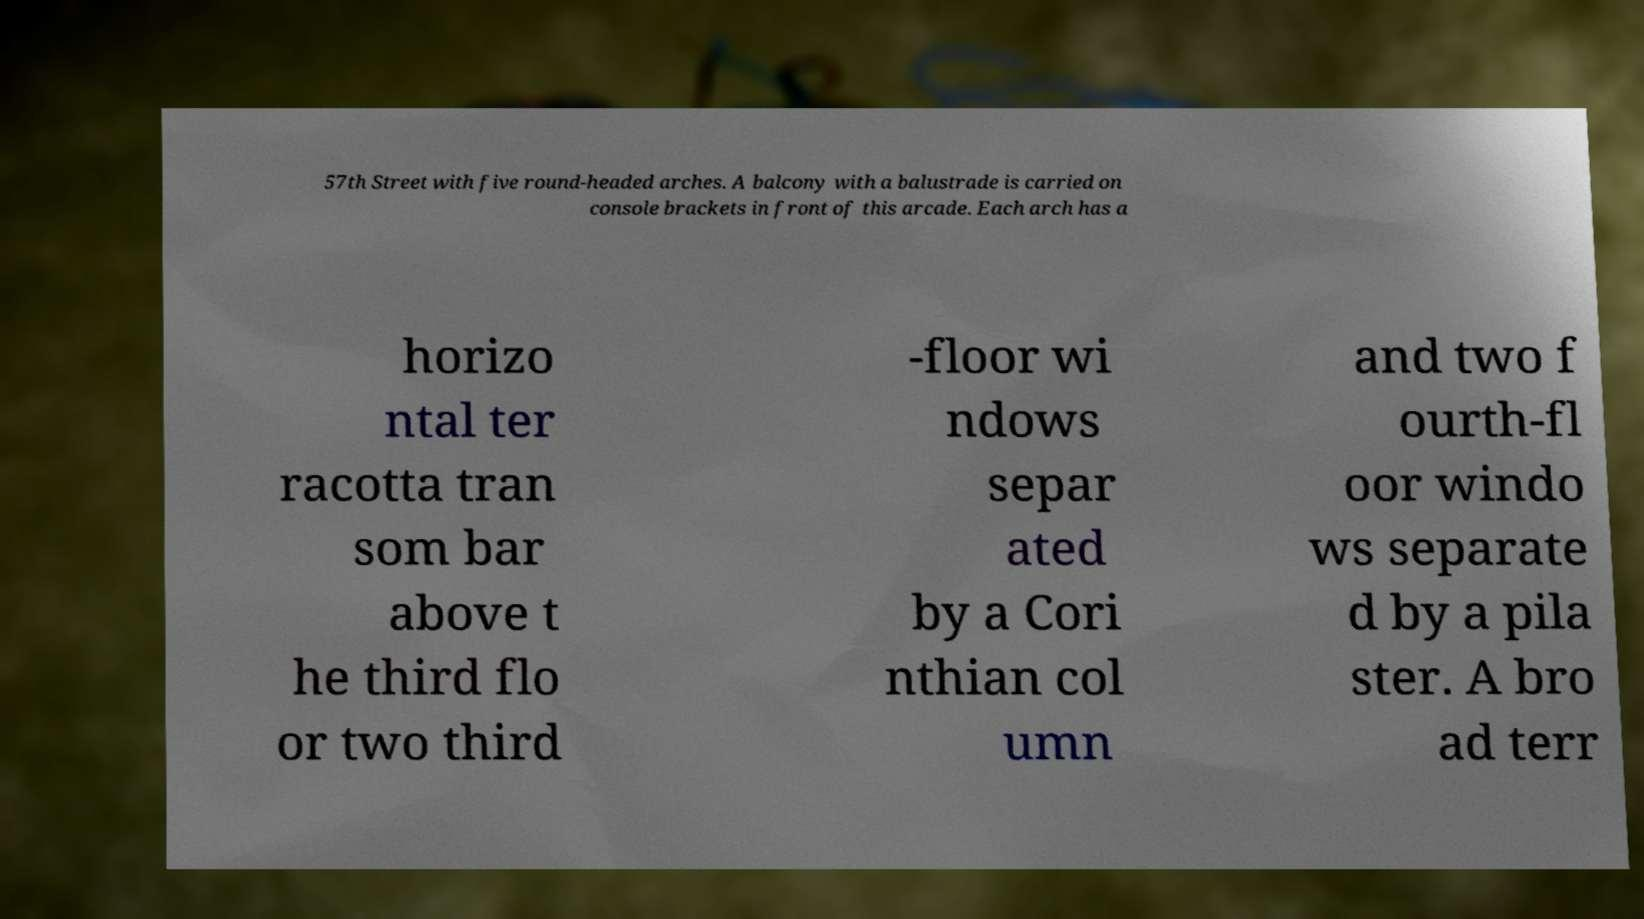Can you read and provide the text displayed in the image?This photo seems to have some interesting text. Can you extract and type it out for me? 57th Street with five round-headed arches. A balcony with a balustrade is carried on console brackets in front of this arcade. Each arch has a horizo ntal ter racotta tran som bar above t he third flo or two third -floor wi ndows separ ated by a Cori nthian col umn and two f ourth-fl oor windo ws separate d by a pila ster. A bro ad terr 